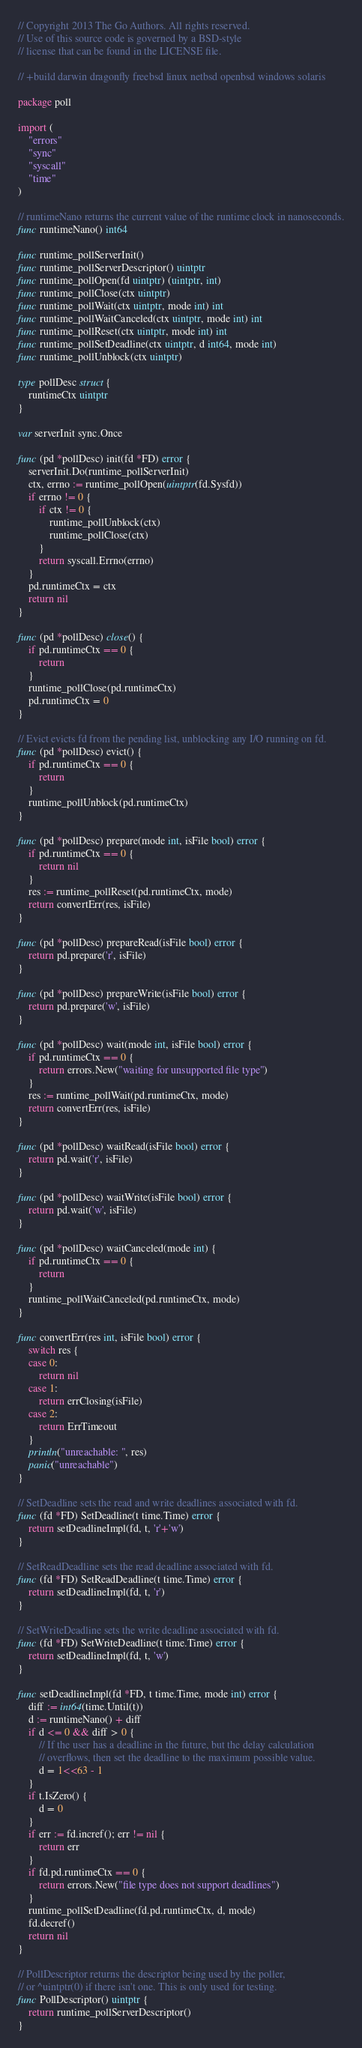Convert code to text. <code><loc_0><loc_0><loc_500><loc_500><_Go_>// Copyright 2013 The Go Authors. All rights reserved.
// Use of this source code is governed by a BSD-style
// license that can be found in the LICENSE file.

// +build darwin dragonfly freebsd linux netbsd openbsd windows solaris

package poll

import (
	"errors"
	"sync"
	"syscall"
	"time"
)

// runtimeNano returns the current value of the runtime clock in nanoseconds.
func runtimeNano() int64

func runtime_pollServerInit()
func runtime_pollServerDescriptor() uintptr
func runtime_pollOpen(fd uintptr) (uintptr, int)
func runtime_pollClose(ctx uintptr)
func runtime_pollWait(ctx uintptr, mode int) int
func runtime_pollWaitCanceled(ctx uintptr, mode int) int
func runtime_pollReset(ctx uintptr, mode int) int
func runtime_pollSetDeadline(ctx uintptr, d int64, mode int)
func runtime_pollUnblock(ctx uintptr)

type pollDesc struct {
	runtimeCtx uintptr
}

var serverInit sync.Once

func (pd *pollDesc) init(fd *FD) error {
	serverInit.Do(runtime_pollServerInit)
	ctx, errno := runtime_pollOpen(uintptr(fd.Sysfd))
	if errno != 0 {
		if ctx != 0 {
			runtime_pollUnblock(ctx)
			runtime_pollClose(ctx)
		}
		return syscall.Errno(errno)
	}
	pd.runtimeCtx = ctx
	return nil
}

func (pd *pollDesc) close() {
	if pd.runtimeCtx == 0 {
		return
	}
	runtime_pollClose(pd.runtimeCtx)
	pd.runtimeCtx = 0
}

// Evict evicts fd from the pending list, unblocking any I/O running on fd.
func (pd *pollDesc) evict() {
	if pd.runtimeCtx == 0 {
		return
	}
	runtime_pollUnblock(pd.runtimeCtx)
}

func (pd *pollDesc) prepare(mode int, isFile bool) error {
	if pd.runtimeCtx == 0 {
		return nil
	}
	res := runtime_pollReset(pd.runtimeCtx, mode)
	return convertErr(res, isFile)
}

func (pd *pollDesc) prepareRead(isFile bool) error {
	return pd.prepare('r', isFile)
}

func (pd *pollDesc) prepareWrite(isFile bool) error {
	return pd.prepare('w', isFile)
}

func (pd *pollDesc) wait(mode int, isFile bool) error {
	if pd.runtimeCtx == 0 {
		return errors.New("waiting for unsupported file type")
	}
	res := runtime_pollWait(pd.runtimeCtx, mode)
	return convertErr(res, isFile)
}

func (pd *pollDesc) waitRead(isFile bool) error {
	return pd.wait('r', isFile)
}

func (pd *pollDesc) waitWrite(isFile bool) error {
	return pd.wait('w', isFile)
}

func (pd *pollDesc) waitCanceled(mode int) {
	if pd.runtimeCtx == 0 {
		return
	}
	runtime_pollWaitCanceled(pd.runtimeCtx, mode)
}

func convertErr(res int, isFile bool) error {
	switch res {
	case 0:
		return nil
	case 1:
		return errClosing(isFile)
	case 2:
		return ErrTimeout
	}
	println("unreachable: ", res)
	panic("unreachable")
}

// SetDeadline sets the read and write deadlines associated with fd.
func (fd *FD) SetDeadline(t time.Time) error {
	return setDeadlineImpl(fd, t, 'r'+'w')
}

// SetReadDeadline sets the read deadline associated with fd.
func (fd *FD) SetReadDeadline(t time.Time) error {
	return setDeadlineImpl(fd, t, 'r')
}

// SetWriteDeadline sets the write deadline associated with fd.
func (fd *FD) SetWriteDeadline(t time.Time) error {
	return setDeadlineImpl(fd, t, 'w')
}

func setDeadlineImpl(fd *FD, t time.Time, mode int) error {
	diff := int64(time.Until(t))
	d := runtimeNano() + diff
	if d <= 0 && diff > 0 {
		// If the user has a deadline in the future, but the delay calculation
		// overflows, then set the deadline to the maximum possible value.
		d = 1<<63 - 1
	}
	if t.IsZero() {
		d = 0
	}
	if err := fd.incref(); err != nil {
		return err
	}
	if fd.pd.runtimeCtx == 0 {
		return errors.New("file type does not support deadlines")
	}
	runtime_pollSetDeadline(fd.pd.runtimeCtx, d, mode)
	fd.decref()
	return nil
}

// PollDescriptor returns the descriptor being used by the poller,
// or ^uintptr(0) if there isn't one. This is only used for testing.
func PollDescriptor() uintptr {
	return runtime_pollServerDescriptor()
}
</code> 